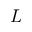Convert formula to latex. <formula><loc_0><loc_0><loc_500><loc_500>L</formula> 